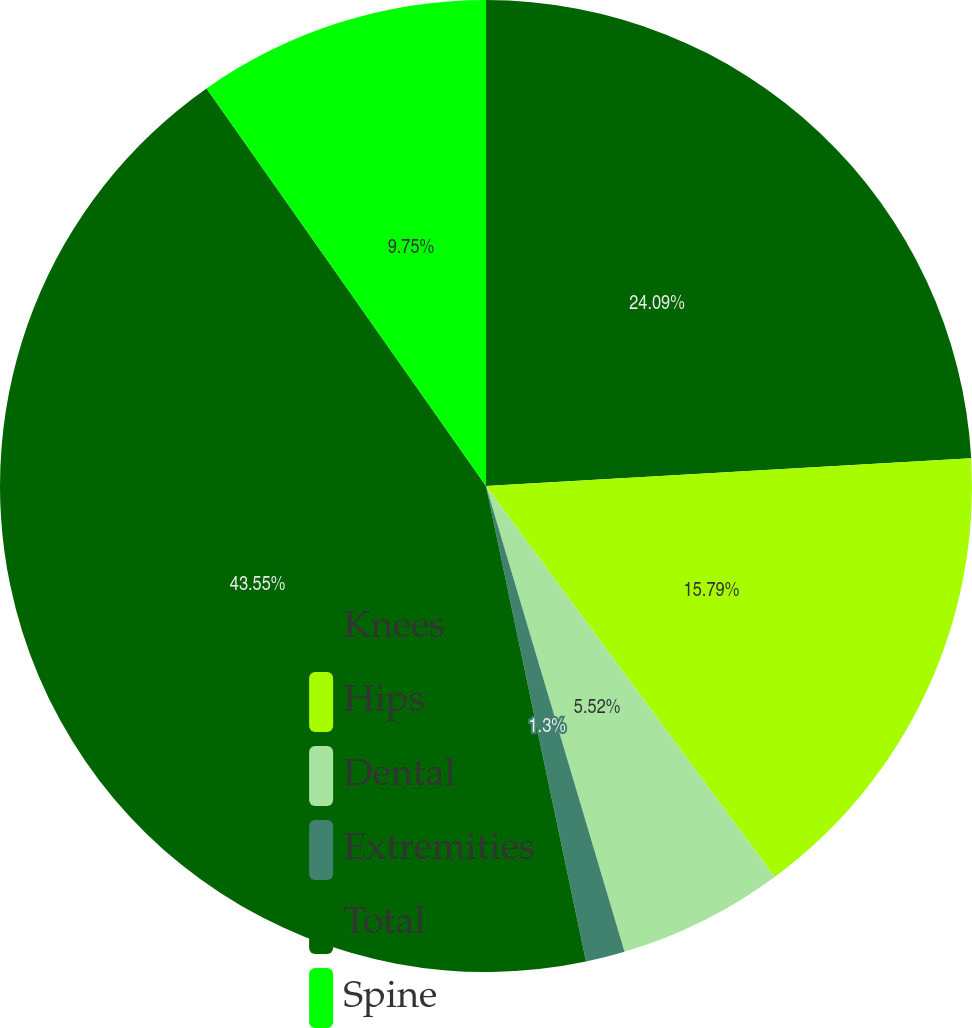Convert chart. <chart><loc_0><loc_0><loc_500><loc_500><pie_chart><fcel>Knees<fcel>Hips<fcel>Dental<fcel>Extremities<fcel>Total<fcel>Spine<nl><fcel>24.09%<fcel>15.79%<fcel>5.52%<fcel>1.3%<fcel>43.55%<fcel>9.75%<nl></chart> 